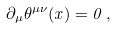Convert formula to latex. <formula><loc_0><loc_0><loc_500><loc_500>\partial _ { \mu } \theta ^ { \mu \nu } ( x ) = 0 \, ,</formula> 